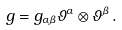Convert formula to latex. <formula><loc_0><loc_0><loc_500><loc_500>g = g _ { \alpha \beta } { \vartheta } ^ { \alpha } \otimes { \vartheta } ^ { \beta } \, .</formula> 